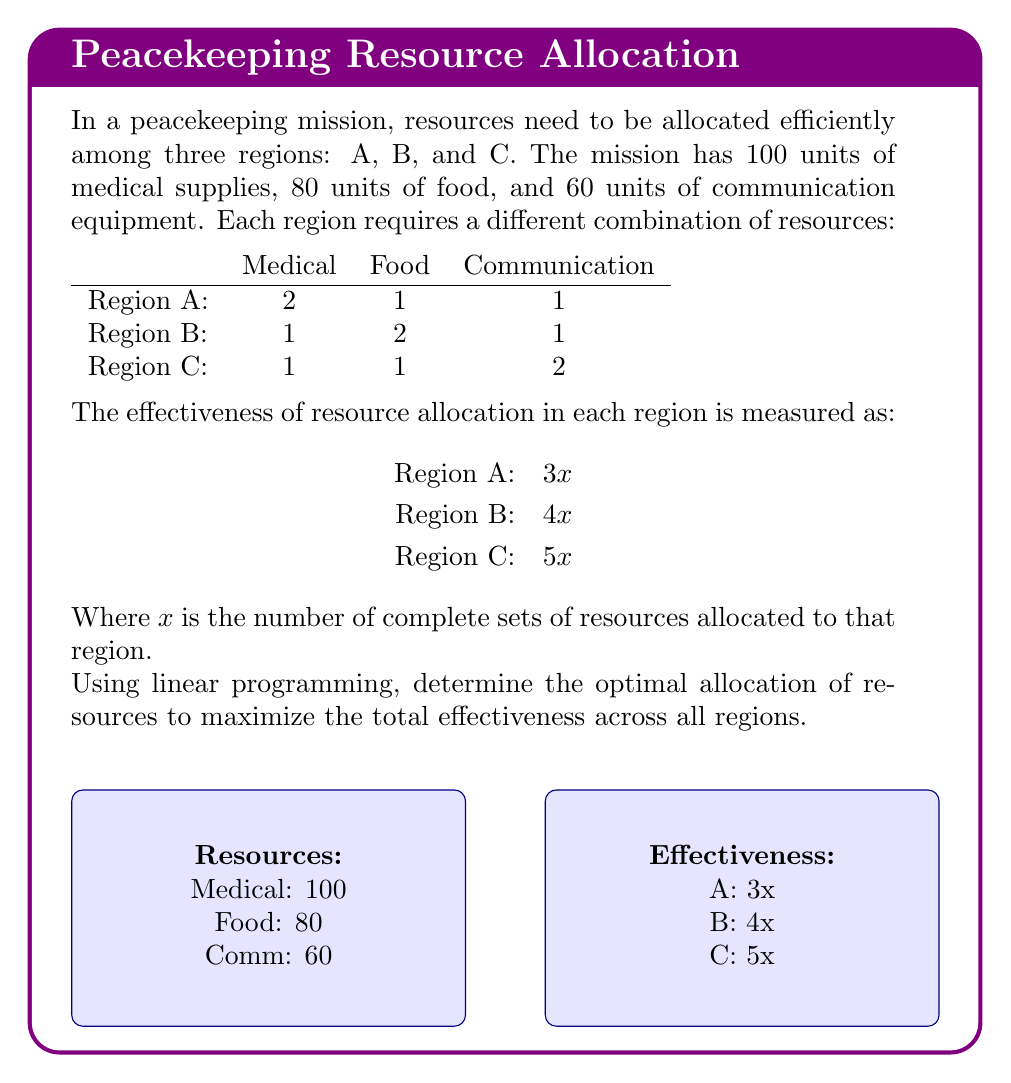Can you answer this question? Let's approach this step-by-step using linear programming:

1) Define variables:
   Let $x_A$, $x_B$, and $x_C$ be the number of complete sets allocated to regions A, B, and C respectively.

2) Objective function:
   Maximize $Z = 3x_A + 4x_B + 5x_C$

3) Constraints:
   Medical: $2x_A + x_B + x_C \leq 100$
   Food: $x_A + 2x_B + x_C \leq 80$
   Communication: $x_A + x_B + 2x_C \leq 60$
   Non-negativity: $x_A, x_B, x_C \geq 0$

4) Solve using the simplex method:

   Initial tableau:
   $$
   \begin{array}{c|cccc|c}
     & x_A & x_B & x_C & Z & RHS \\
   \hline
   Z & -3 & -4 & -5 & 1 & 0 \\
   S_1 & 2 & 1 & 1 & 0 & 100 \\
   S_2 & 1 & 2 & 1 & 0 & 80 \\
   S_3 & 1 & 1 & 2 & 0 & 60 \\
   \end{array}
   $$

   After iterations, we reach the optimal solution:
   $$
   \begin{array}{c|cccc|c}
     & x_A & x_B & x_C & Z & RHS \\
   \hline
   Z & 0 & 0 & 0 & 1 & 220 \\
   x_A & 1 & 0 & 0 & 0 & 20 \\
   x_B & 0 & 1 & 0 & 0 & 30 \\
   x_C & 0 & 0 & 1 & 0 & 20 \\
   \end{array}
   $$

5) Interpret the results:
   Optimal allocation:
   Region A: 20 sets
   Region B: 30 sets
   Region C: 20 sets

   Maximum effectiveness: $Z = 3(20) + 4(30) + 5(20) = 220$

6) Verify resource usage:
   Medical: $2(20) + 1(30) + 1(20) = 100$
   Food: $1(20) + 2(30) + 1(20) = 100$
   Communication: $1(20) + 1(30) + 2(20) = 90$

   All constraints are satisfied, and resources are fully utilized except for 10 units of communication equipment.
Answer: Optimal allocation: A: 20, B: 30, C: 20; Maximum effectiveness: 220 